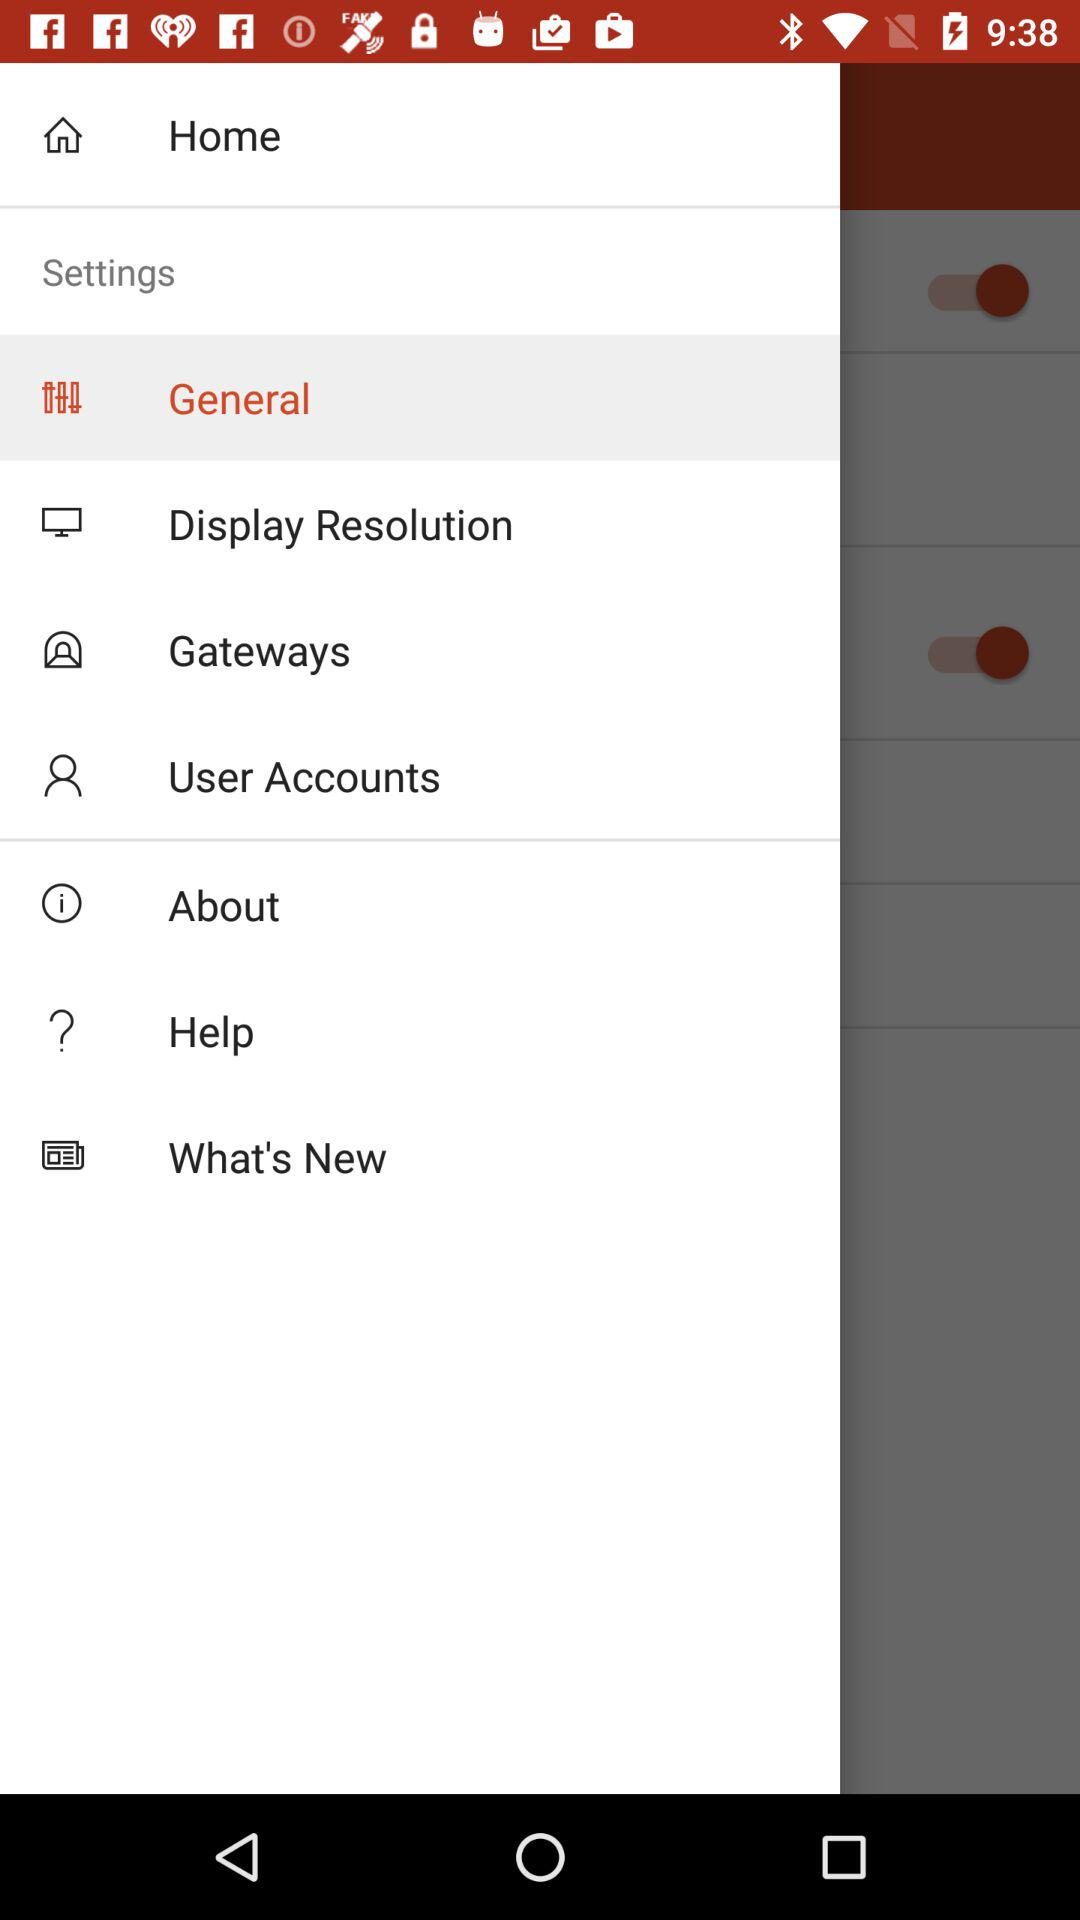How many switches are on the screen?
Answer the question using a single word or phrase. 2 